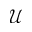Convert formula to latex. <formula><loc_0><loc_0><loc_500><loc_500>\mathcal { U }</formula> 